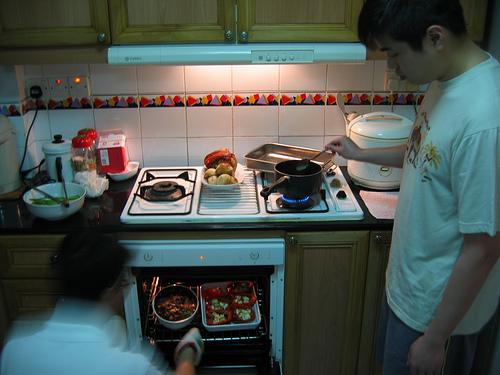What kind of range is the stovetop?
Keep it brief. Gas. What kind of gloves are they wearing?
Quick response, please. Oven mitts. What is in the baking center?
Concise answer only. Peppers. What is the man holding?
Concise answer only. Spoon. Does the man in the picture know what he wants to eat?
Be succinct. Yes. Is the oven full of food right now?
Give a very brief answer. Yes. What room is shown?
Keep it brief. Kitchen. 